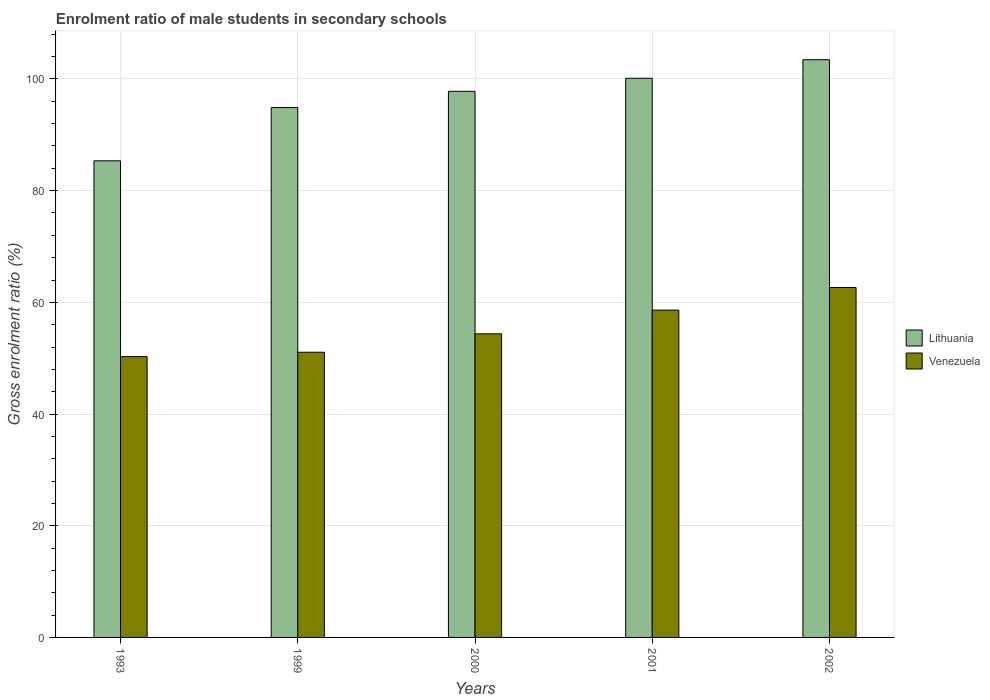How many different coloured bars are there?
Offer a terse response. 2. Are the number of bars per tick equal to the number of legend labels?
Give a very brief answer. Yes. Are the number of bars on each tick of the X-axis equal?
Ensure brevity in your answer.  Yes. How many bars are there on the 1st tick from the right?
Provide a succinct answer. 2. In how many cases, is the number of bars for a given year not equal to the number of legend labels?
Keep it short and to the point. 0. What is the enrolment ratio of male students in secondary schools in Venezuela in 2002?
Keep it short and to the point. 62.66. Across all years, what is the maximum enrolment ratio of male students in secondary schools in Lithuania?
Make the answer very short. 103.45. Across all years, what is the minimum enrolment ratio of male students in secondary schools in Lithuania?
Provide a succinct answer. 85.34. In which year was the enrolment ratio of male students in secondary schools in Venezuela maximum?
Your answer should be very brief. 2002. In which year was the enrolment ratio of male students in secondary schools in Lithuania minimum?
Your answer should be very brief. 1993. What is the total enrolment ratio of male students in secondary schools in Lithuania in the graph?
Ensure brevity in your answer.  481.58. What is the difference between the enrolment ratio of male students in secondary schools in Venezuela in 2000 and that in 2001?
Provide a succinct answer. -4.24. What is the difference between the enrolment ratio of male students in secondary schools in Lithuania in 2002 and the enrolment ratio of male students in secondary schools in Venezuela in 1999?
Make the answer very short. 52.38. What is the average enrolment ratio of male students in secondary schools in Venezuela per year?
Ensure brevity in your answer.  55.4. In the year 1993, what is the difference between the enrolment ratio of male students in secondary schools in Lithuania and enrolment ratio of male students in secondary schools in Venezuela?
Your answer should be compact. 35.06. In how many years, is the enrolment ratio of male students in secondary schools in Venezuela greater than 64 %?
Keep it short and to the point. 0. What is the ratio of the enrolment ratio of male students in secondary schools in Lithuania in 1993 to that in 1999?
Give a very brief answer. 0.9. Is the enrolment ratio of male students in secondary schools in Venezuela in 2000 less than that in 2001?
Offer a terse response. Yes. What is the difference between the highest and the second highest enrolment ratio of male students in secondary schools in Lithuania?
Provide a short and direct response. 3.32. What is the difference between the highest and the lowest enrolment ratio of male students in secondary schools in Venezuela?
Provide a succinct answer. 12.38. Is the sum of the enrolment ratio of male students in secondary schools in Lithuania in 1993 and 2001 greater than the maximum enrolment ratio of male students in secondary schools in Venezuela across all years?
Give a very brief answer. Yes. What does the 1st bar from the left in 1993 represents?
Offer a very short reply. Lithuania. What does the 2nd bar from the right in 2000 represents?
Your response must be concise. Lithuania. Does the graph contain any zero values?
Your response must be concise. No. Where does the legend appear in the graph?
Your response must be concise. Center right. How many legend labels are there?
Make the answer very short. 2. What is the title of the graph?
Give a very brief answer. Enrolment ratio of male students in secondary schools. Does "Italy" appear as one of the legend labels in the graph?
Ensure brevity in your answer.  No. What is the label or title of the Y-axis?
Offer a terse response. Gross enrolment ratio (%). What is the Gross enrolment ratio (%) of Lithuania in 1993?
Ensure brevity in your answer.  85.34. What is the Gross enrolment ratio (%) in Venezuela in 1993?
Give a very brief answer. 50.28. What is the Gross enrolment ratio (%) of Lithuania in 1999?
Give a very brief answer. 94.88. What is the Gross enrolment ratio (%) of Venezuela in 1999?
Provide a succinct answer. 51.07. What is the Gross enrolment ratio (%) in Lithuania in 2000?
Your answer should be compact. 97.79. What is the Gross enrolment ratio (%) of Venezuela in 2000?
Provide a succinct answer. 54.36. What is the Gross enrolment ratio (%) of Lithuania in 2001?
Your answer should be compact. 100.12. What is the Gross enrolment ratio (%) of Venezuela in 2001?
Your answer should be compact. 58.61. What is the Gross enrolment ratio (%) in Lithuania in 2002?
Provide a short and direct response. 103.45. What is the Gross enrolment ratio (%) of Venezuela in 2002?
Ensure brevity in your answer.  62.66. Across all years, what is the maximum Gross enrolment ratio (%) of Lithuania?
Offer a terse response. 103.45. Across all years, what is the maximum Gross enrolment ratio (%) of Venezuela?
Offer a terse response. 62.66. Across all years, what is the minimum Gross enrolment ratio (%) in Lithuania?
Your answer should be very brief. 85.34. Across all years, what is the minimum Gross enrolment ratio (%) in Venezuela?
Keep it short and to the point. 50.28. What is the total Gross enrolment ratio (%) of Lithuania in the graph?
Offer a terse response. 481.58. What is the total Gross enrolment ratio (%) of Venezuela in the graph?
Your response must be concise. 276.98. What is the difference between the Gross enrolment ratio (%) in Lithuania in 1993 and that in 1999?
Provide a short and direct response. -9.54. What is the difference between the Gross enrolment ratio (%) in Venezuela in 1993 and that in 1999?
Offer a terse response. -0.78. What is the difference between the Gross enrolment ratio (%) of Lithuania in 1993 and that in 2000?
Your answer should be very brief. -12.45. What is the difference between the Gross enrolment ratio (%) in Venezuela in 1993 and that in 2000?
Keep it short and to the point. -4.08. What is the difference between the Gross enrolment ratio (%) in Lithuania in 1993 and that in 2001?
Your response must be concise. -14.78. What is the difference between the Gross enrolment ratio (%) of Venezuela in 1993 and that in 2001?
Provide a short and direct response. -8.33. What is the difference between the Gross enrolment ratio (%) in Lithuania in 1993 and that in 2002?
Offer a very short reply. -18.1. What is the difference between the Gross enrolment ratio (%) of Venezuela in 1993 and that in 2002?
Your answer should be compact. -12.38. What is the difference between the Gross enrolment ratio (%) of Lithuania in 1999 and that in 2000?
Provide a succinct answer. -2.91. What is the difference between the Gross enrolment ratio (%) in Venezuela in 1999 and that in 2000?
Make the answer very short. -3.3. What is the difference between the Gross enrolment ratio (%) in Lithuania in 1999 and that in 2001?
Provide a short and direct response. -5.24. What is the difference between the Gross enrolment ratio (%) in Venezuela in 1999 and that in 2001?
Your response must be concise. -7.54. What is the difference between the Gross enrolment ratio (%) in Lithuania in 1999 and that in 2002?
Offer a very short reply. -8.57. What is the difference between the Gross enrolment ratio (%) of Venezuela in 1999 and that in 2002?
Offer a very short reply. -11.59. What is the difference between the Gross enrolment ratio (%) in Lithuania in 2000 and that in 2001?
Keep it short and to the point. -2.34. What is the difference between the Gross enrolment ratio (%) in Venezuela in 2000 and that in 2001?
Provide a succinct answer. -4.24. What is the difference between the Gross enrolment ratio (%) in Lithuania in 2000 and that in 2002?
Ensure brevity in your answer.  -5.66. What is the difference between the Gross enrolment ratio (%) in Venezuela in 2000 and that in 2002?
Your answer should be compact. -8.29. What is the difference between the Gross enrolment ratio (%) in Lithuania in 2001 and that in 2002?
Keep it short and to the point. -3.32. What is the difference between the Gross enrolment ratio (%) in Venezuela in 2001 and that in 2002?
Keep it short and to the point. -4.05. What is the difference between the Gross enrolment ratio (%) of Lithuania in 1993 and the Gross enrolment ratio (%) of Venezuela in 1999?
Offer a terse response. 34.28. What is the difference between the Gross enrolment ratio (%) in Lithuania in 1993 and the Gross enrolment ratio (%) in Venezuela in 2000?
Your response must be concise. 30.98. What is the difference between the Gross enrolment ratio (%) in Lithuania in 1993 and the Gross enrolment ratio (%) in Venezuela in 2001?
Your response must be concise. 26.73. What is the difference between the Gross enrolment ratio (%) in Lithuania in 1993 and the Gross enrolment ratio (%) in Venezuela in 2002?
Your answer should be compact. 22.68. What is the difference between the Gross enrolment ratio (%) in Lithuania in 1999 and the Gross enrolment ratio (%) in Venezuela in 2000?
Keep it short and to the point. 40.52. What is the difference between the Gross enrolment ratio (%) in Lithuania in 1999 and the Gross enrolment ratio (%) in Venezuela in 2001?
Make the answer very short. 36.27. What is the difference between the Gross enrolment ratio (%) of Lithuania in 1999 and the Gross enrolment ratio (%) of Venezuela in 2002?
Make the answer very short. 32.22. What is the difference between the Gross enrolment ratio (%) in Lithuania in 2000 and the Gross enrolment ratio (%) in Venezuela in 2001?
Make the answer very short. 39.18. What is the difference between the Gross enrolment ratio (%) in Lithuania in 2000 and the Gross enrolment ratio (%) in Venezuela in 2002?
Your response must be concise. 35.13. What is the difference between the Gross enrolment ratio (%) in Lithuania in 2001 and the Gross enrolment ratio (%) in Venezuela in 2002?
Provide a succinct answer. 37.47. What is the average Gross enrolment ratio (%) of Lithuania per year?
Provide a succinct answer. 96.32. What is the average Gross enrolment ratio (%) of Venezuela per year?
Make the answer very short. 55.4. In the year 1993, what is the difference between the Gross enrolment ratio (%) in Lithuania and Gross enrolment ratio (%) in Venezuela?
Give a very brief answer. 35.06. In the year 1999, what is the difference between the Gross enrolment ratio (%) in Lithuania and Gross enrolment ratio (%) in Venezuela?
Offer a very short reply. 43.82. In the year 2000, what is the difference between the Gross enrolment ratio (%) of Lithuania and Gross enrolment ratio (%) of Venezuela?
Provide a short and direct response. 43.42. In the year 2001, what is the difference between the Gross enrolment ratio (%) in Lithuania and Gross enrolment ratio (%) in Venezuela?
Provide a short and direct response. 41.51. In the year 2002, what is the difference between the Gross enrolment ratio (%) of Lithuania and Gross enrolment ratio (%) of Venezuela?
Provide a succinct answer. 40.79. What is the ratio of the Gross enrolment ratio (%) in Lithuania in 1993 to that in 1999?
Offer a very short reply. 0.9. What is the ratio of the Gross enrolment ratio (%) of Venezuela in 1993 to that in 1999?
Give a very brief answer. 0.98. What is the ratio of the Gross enrolment ratio (%) in Lithuania in 1993 to that in 2000?
Ensure brevity in your answer.  0.87. What is the ratio of the Gross enrolment ratio (%) in Venezuela in 1993 to that in 2000?
Offer a terse response. 0.92. What is the ratio of the Gross enrolment ratio (%) of Lithuania in 1993 to that in 2001?
Ensure brevity in your answer.  0.85. What is the ratio of the Gross enrolment ratio (%) in Venezuela in 1993 to that in 2001?
Offer a very short reply. 0.86. What is the ratio of the Gross enrolment ratio (%) of Lithuania in 1993 to that in 2002?
Provide a short and direct response. 0.82. What is the ratio of the Gross enrolment ratio (%) of Venezuela in 1993 to that in 2002?
Provide a short and direct response. 0.8. What is the ratio of the Gross enrolment ratio (%) in Lithuania in 1999 to that in 2000?
Provide a short and direct response. 0.97. What is the ratio of the Gross enrolment ratio (%) of Venezuela in 1999 to that in 2000?
Make the answer very short. 0.94. What is the ratio of the Gross enrolment ratio (%) of Lithuania in 1999 to that in 2001?
Your answer should be compact. 0.95. What is the ratio of the Gross enrolment ratio (%) of Venezuela in 1999 to that in 2001?
Provide a succinct answer. 0.87. What is the ratio of the Gross enrolment ratio (%) of Lithuania in 1999 to that in 2002?
Give a very brief answer. 0.92. What is the ratio of the Gross enrolment ratio (%) of Venezuela in 1999 to that in 2002?
Keep it short and to the point. 0.81. What is the ratio of the Gross enrolment ratio (%) of Lithuania in 2000 to that in 2001?
Your response must be concise. 0.98. What is the ratio of the Gross enrolment ratio (%) in Venezuela in 2000 to that in 2001?
Your answer should be very brief. 0.93. What is the ratio of the Gross enrolment ratio (%) in Lithuania in 2000 to that in 2002?
Offer a very short reply. 0.95. What is the ratio of the Gross enrolment ratio (%) of Venezuela in 2000 to that in 2002?
Your answer should be very brief. 0.87. What is the ratio of the Gross enrolment ratio (%) of Lithuania in 2001 to that in 2002?
Make the answer very short. 0.97. What is the ratio of the Gross enrolment ratio (%) of Venezuela in 2001 to that in 2002?
Your response must be concise. 0.94. What is the difference between the highest and the second highest Gross enrolment ratio (%) of Lithuania?
Your response must be concise. 3.32. What is the difference between the highest and the second highest Gross enrolment ratio (%) of Venezuela?
Give a very brief answer. 4.05. What is the difference between the highest and the lowest Gross enrolment ratio (%) in Lithuania?
Give a very brief answer. 18.1. What is the difference between the highest and the lowest Gross enrolment ratio (%) of Venezuela?
Your response must be concise. 12.38. 